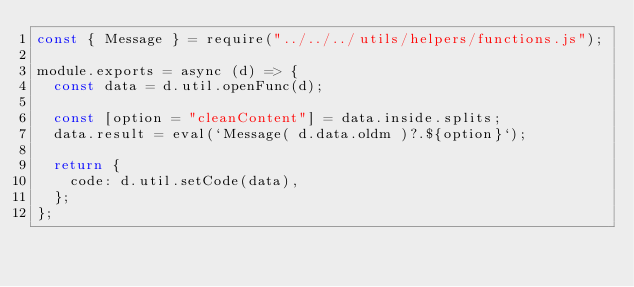Convert code to text. <code><loc_0><loc_0><loc_500><loc_500><_JavaScript_>const { Message } = require("../../../utils/helpers/functions.js");

module.exports = async (d) => {
	const data = d.util.openFunc(d);

	const [option = "cleanContent"] = data.inside.splits;
	data.result = eval(`Message( d.data.oldm )?.${option}`);

	return {
		code: d.util.setCode(data),
	};
};
</code> 